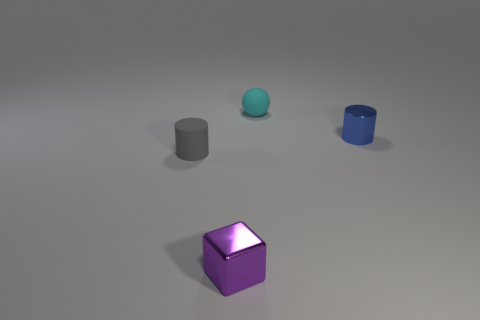The rubber object that is on the right side of the cylinder in front of the object that is to the right of the small matte sphere is what shape?
Give a very brief answer. Sphere. How big is the blue object?
Provide a short and direct response. Small. Is there a cyan cube that has the same material as the tiny cyan thing?
Ensure brevity in your answer.  No. There is another object that is the same shape as the blue thing; what size is it?
Make the answer very short. Small. Is the number of tiny blue metal things on the left side of the small purple block the same as the number of small cylinders?
Ensure brevity in your answer.  No. There is a tiny shiny object that is on the right side of the matte sphere; is its shape the same as the gray thing?
Provide a short and direct response. Yes. The blue shiny object is what shape?
Offer a very short reply. Cylinder. What material is the gray cylinder left of the rubber thing that is on the right side of the cylinder that is in front of the small blue metal object?
Your answer should be compact. Rubber. How many things are either big cyan cylinders or gray matte cylinders?
Provide a short and direct response. 1. Do the cylinder that is to the right of the cyan rubber sphere and the tiny cyan sphere have the same material?
Ensure brevity in your answer.  No. 